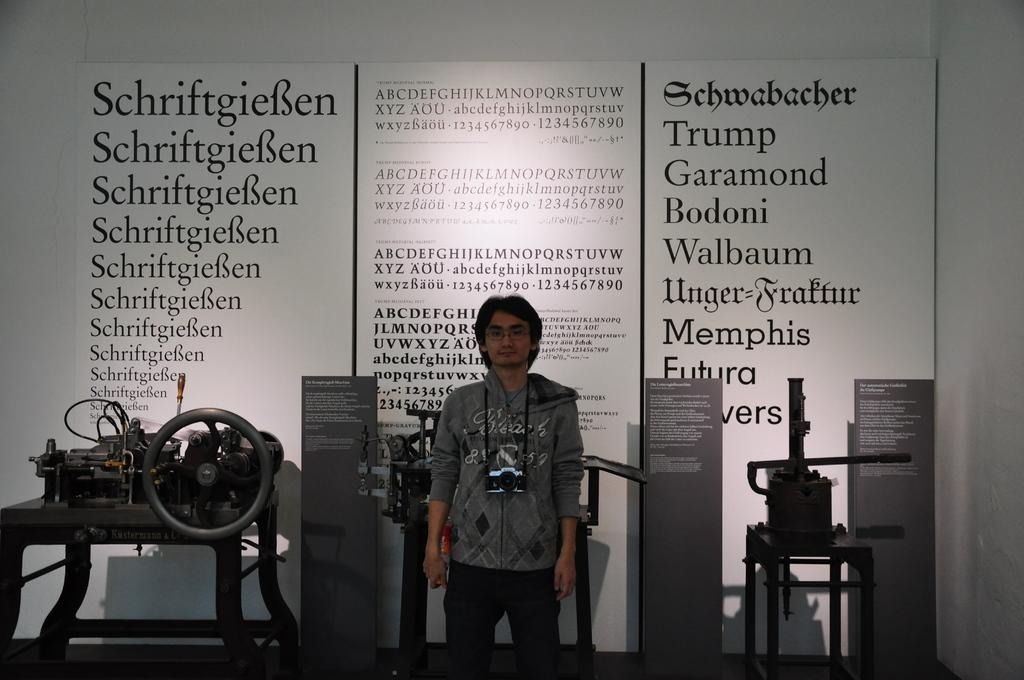What is the main subject of the image? The main subject of the image is a man. What is the man wearing in the image? The man is wearing a grey t-shirt in the image. What is the man holding in the image? The man is holding a camera in the image. Where is the man positioned in the image? The man is standing in the middle of the image. What can be seen behind the man in the image? There are machineries behind the man, and a wall with text behind the machineries. What type of cable can be seen hanging from the man's collar in the image? There is no cable hanging from the man's collar in the image, nor is there a collar visible. 